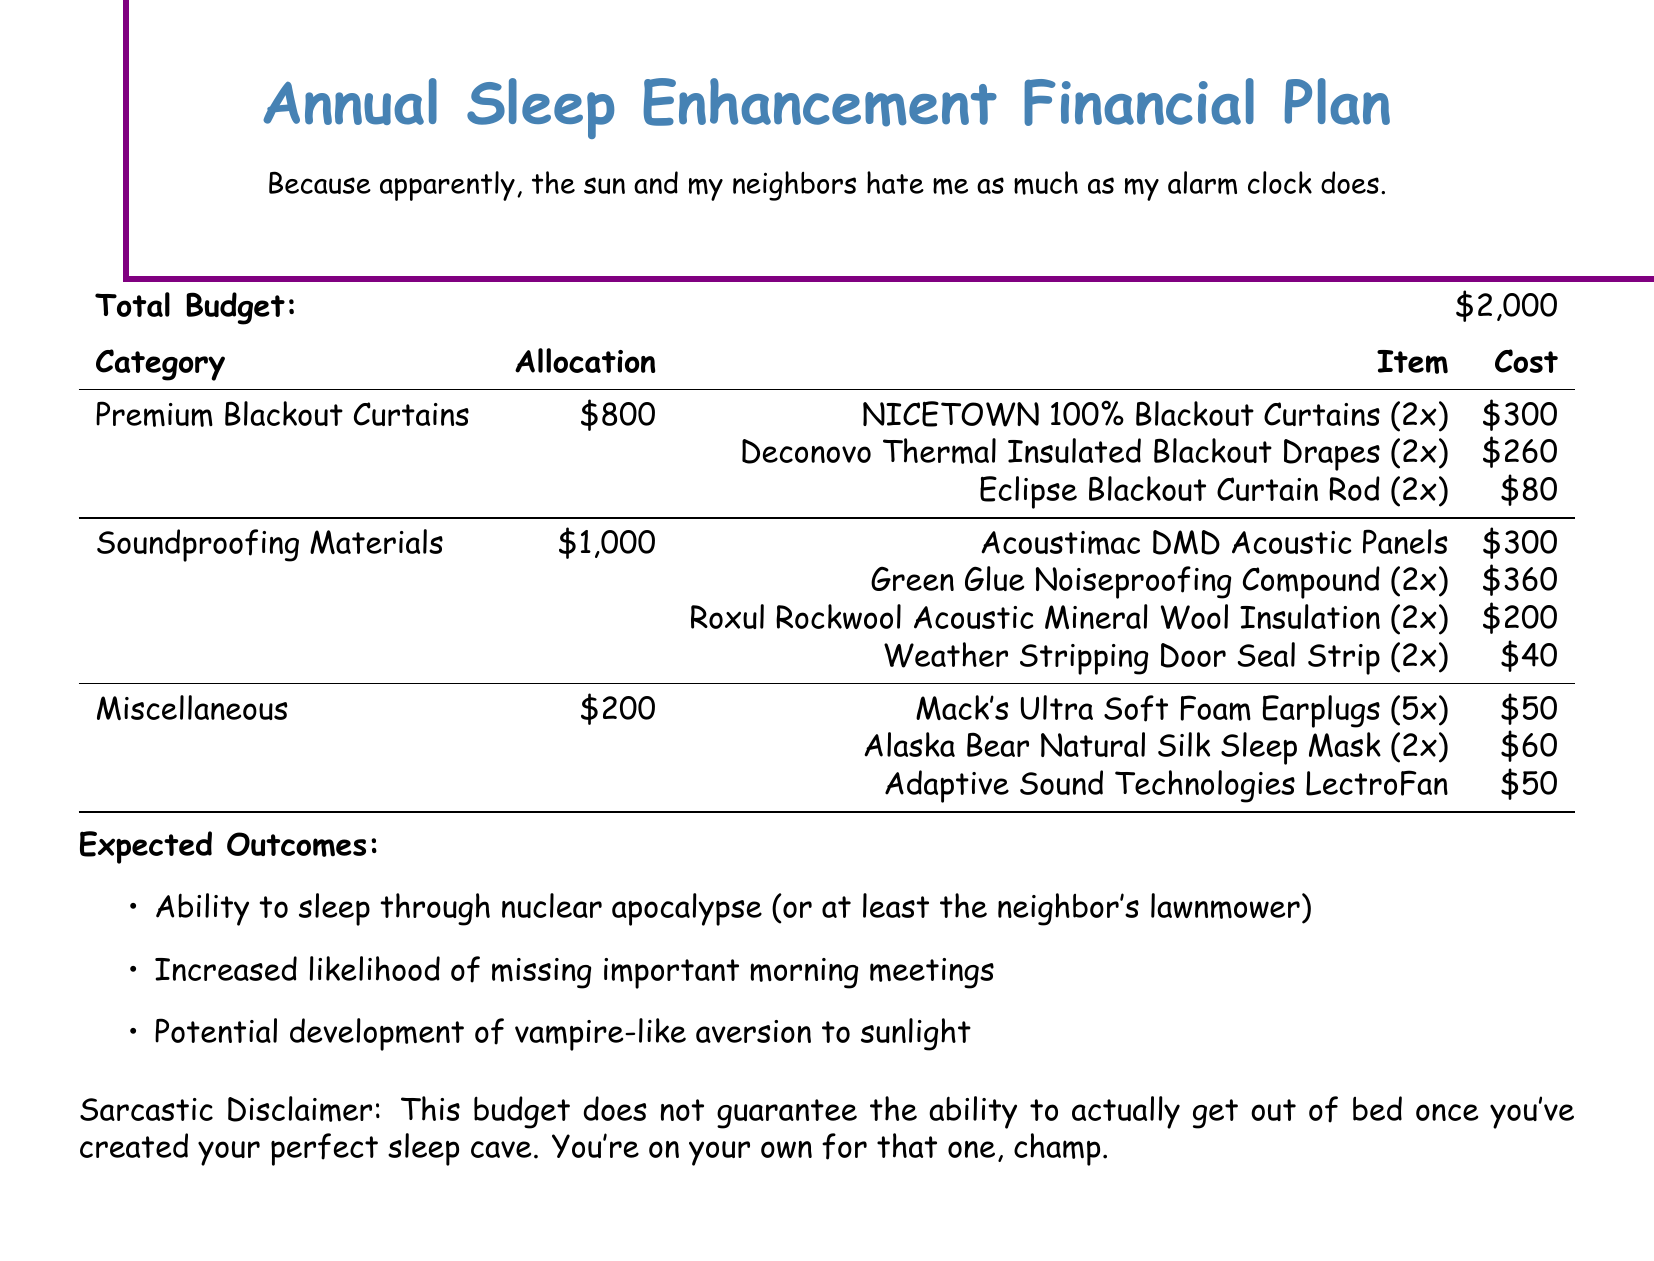What is the total budget? The total budget is clearly stated in the document as $2,000.
Answer: $2,000 How much is allocated for premium blackout curtains? The allocation for premium blackout curtains is specified in the budget section as $800.
Answer: $800 What are the two types of blackout curtains listed? The document lists NICETOWN 100% Blackout Curtains and Deconovo Thermal Insulated Blackout Drapes.
Answer: NICETOWN 100% Blackout Curtains, Deconovo Thermal Insulated Blackout Drapes How much does the Green Glue Noiseproofing Compound cost? The cost for the Green Glue Noiseproofing Compound is mentioned as $360.
Answer: $360 What is the total amount allocated for soundproofing materials? The total allocated for soundproofing materials is given in the document as $1,000.
Answer: $1,000 What is one expected outcome mentioned in the document? An expected outcome includes the ability to sleep through the neighbor's lawnmower.
Answer: Ability to sleep through nuclear apocalypse (or at least the neighbor's lawnmower) How much is being spent on miscellaneous items? The budget allocates $200 for miscellaneous items, as indicated in the table.
Answer: $200 How many sets of blackout curtains are included? The document explicitly states that two sets of NICETOWN blackout curtains and two sets of Deconovo drapes are included.
Answer: 2 What type of earplugs are mentioned in the miscellaneous section? The document mentions Mack's Ultra Soft Foam Earplugs in the miscellaneous section.
Answer: Mack's Ultra Soft Foam Earplugs 